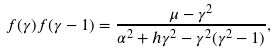<formula> <loc_0><loc_0><loc_500><loc_500>f ( \gamma ) f ( \gamma - 1 ) = \frac { \mu - \gamma ^ { 2 } } { \alpha ^ { 2 } + h \gamma ^ { 2 } - \gamma ^ { 2 } ( \gamma ^ { 2 } - 1 ) } ,</formula> 